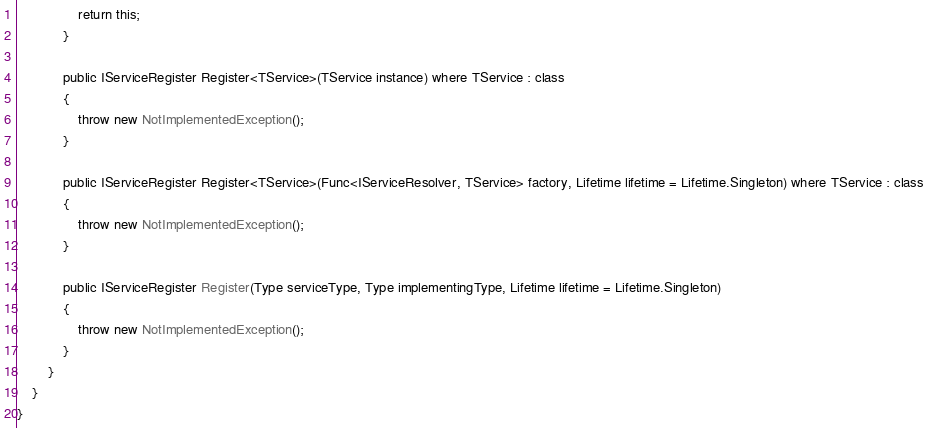Convert code to text. <code><loc_0><loc_0><loc_500><loc_500><_C#_>                return this;
            }

            public IServiceRegister Register<TService>(TService instance) where TService : class
            {
                throw new NotImplementedException();
            }

            public IServiceRegister Register<TService>(Func<IServiceResolver, TService> factory, Lifetime lifetime = Lifetime.Singleton) where TService : class
            {
                throw new NotImplementedException();
            }

            public IServiceRegister Register(Type serviceType, Type implementingType, Lifetime lifetime = Lifetime.Singleton)
            {
                throw new NotImplementedException();
            }
        }
    }
}
</code> 